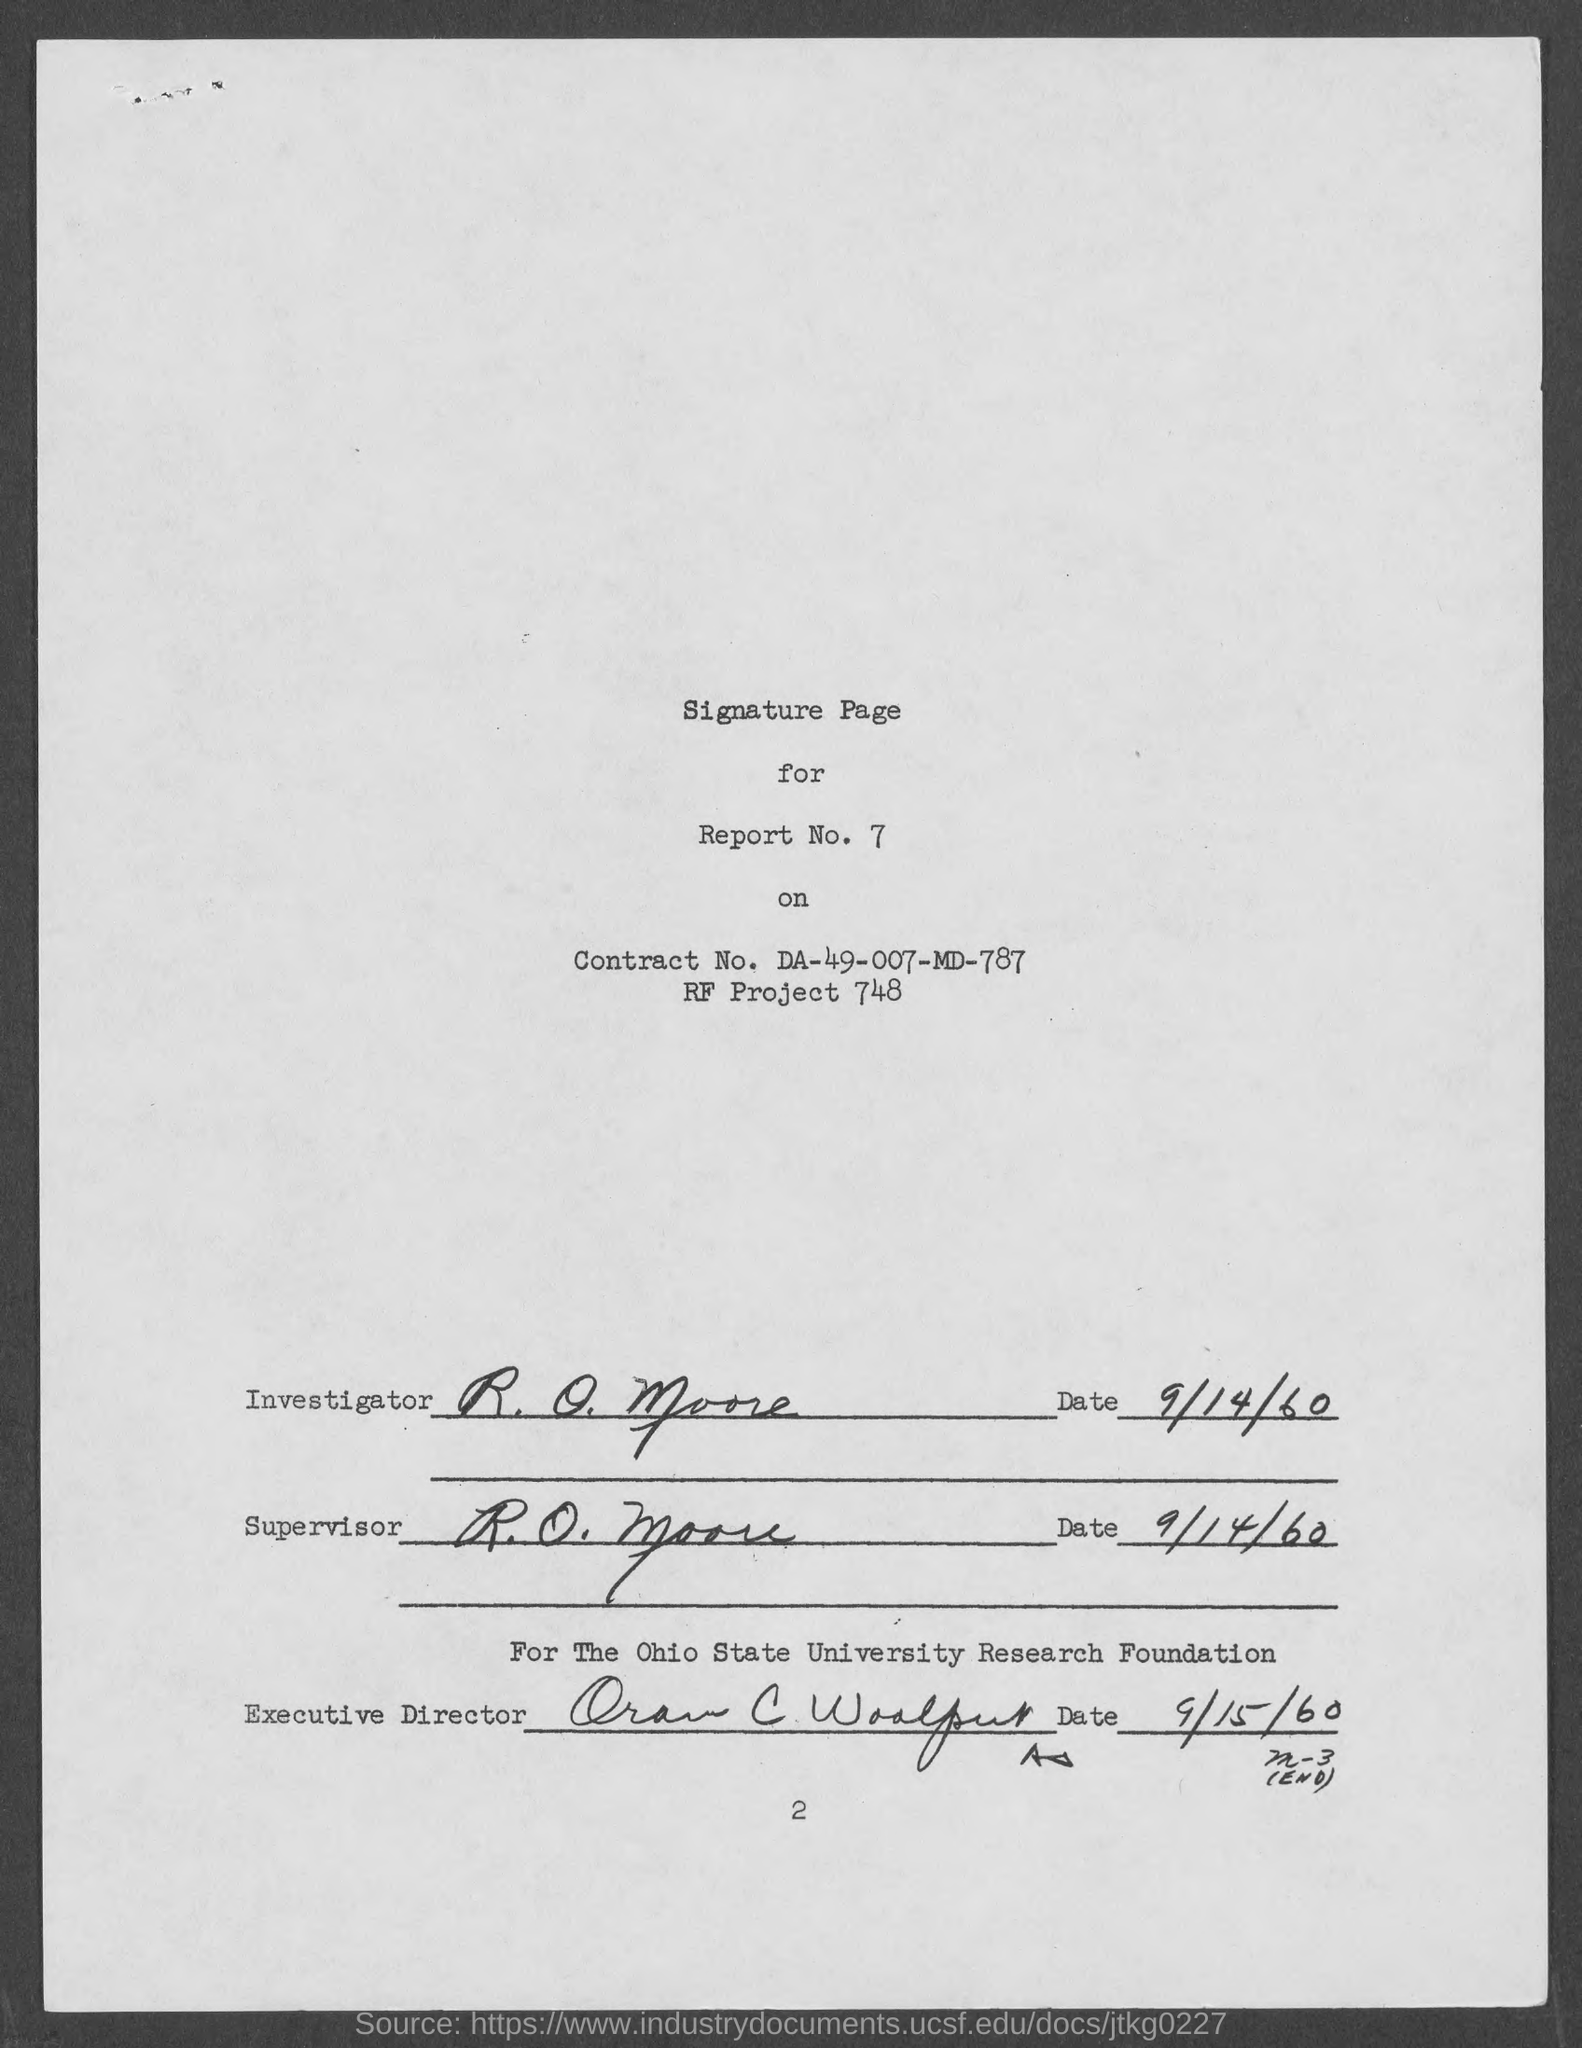Point out several critical features in this image. What is report number 7..?" is a question asking for information about a specific report. RF project number 748... has been assigned. The date corresponding to the word 'Supervisor' is September 14, 1960. 